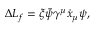<formula> <loc_0><loc_0><loc_500><loc_500>\Delta L _ { f } = \xi \bar { \psi } \gamma ^ { \mu } \dot { x } _ { \mu } \psi ,</formula> 